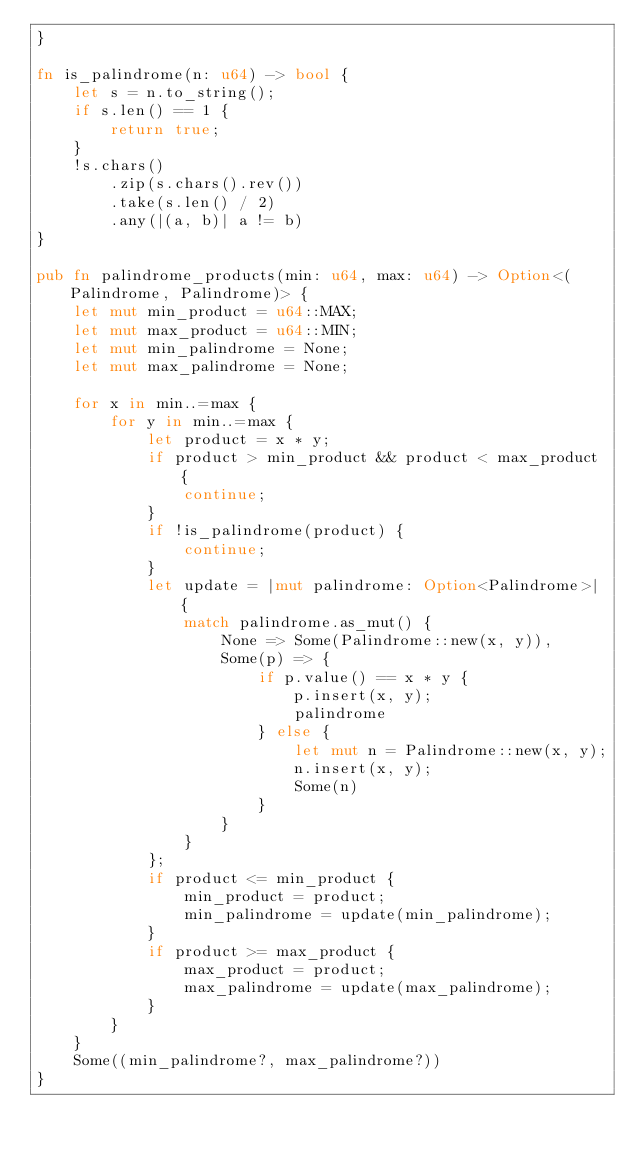<code> <loc_0><loc_0><loc_500><loc_500><_Rust_>}

fn is_palindrome(n: u64) -> bool {
    let s = n.to_string();
    if s.len() == 1 {
        return true;
    }
    !s.chars()
        .zip(s.chars().rev())
        .take(s.len() / 2)
        .any(|(a, b)| a != b)
}

pub fn palindrome_products(min: u64, max: u64) -> Option<(Palindrome, Palindrome)> {
    let mut min_product = u64::MAX;
    let mut max_product = u64::MIN;
    let mut min_palindrome = None;
    let mut max_palindrome = None;

    for x in min..=max {
        for y in min..=max {
            let product = x * y;
            if product > min_product && product < max_product {
                continue;
            }
            if !is_palindrome(product) {
                continue;
            }
            let update = |mut palindrome: Option<Palindrome>| {
                match palindrome.as_mut() {
                    None => Some(Palindrome::new(x, y)),
                    Some(p) => {
                        if p.value() == x * y {
                            p.insert(x, y);
                            palindrome
                        } else {
                            let mut n = Palindrome::new(x, y);
                            n.insert(x, y);
                            Some(n)
                        }
                    }
                }
            };
            if product <= min_product {
                min_product = product;
                min_palindrome = update(min_palindrome);
            }
            if product >= max_product {
                max_product = product;
                max_palindrome = update(max_palindrome);
            }
        }
    }
    Some((min_palindrome?, max_palindrome?))
}
</code> 